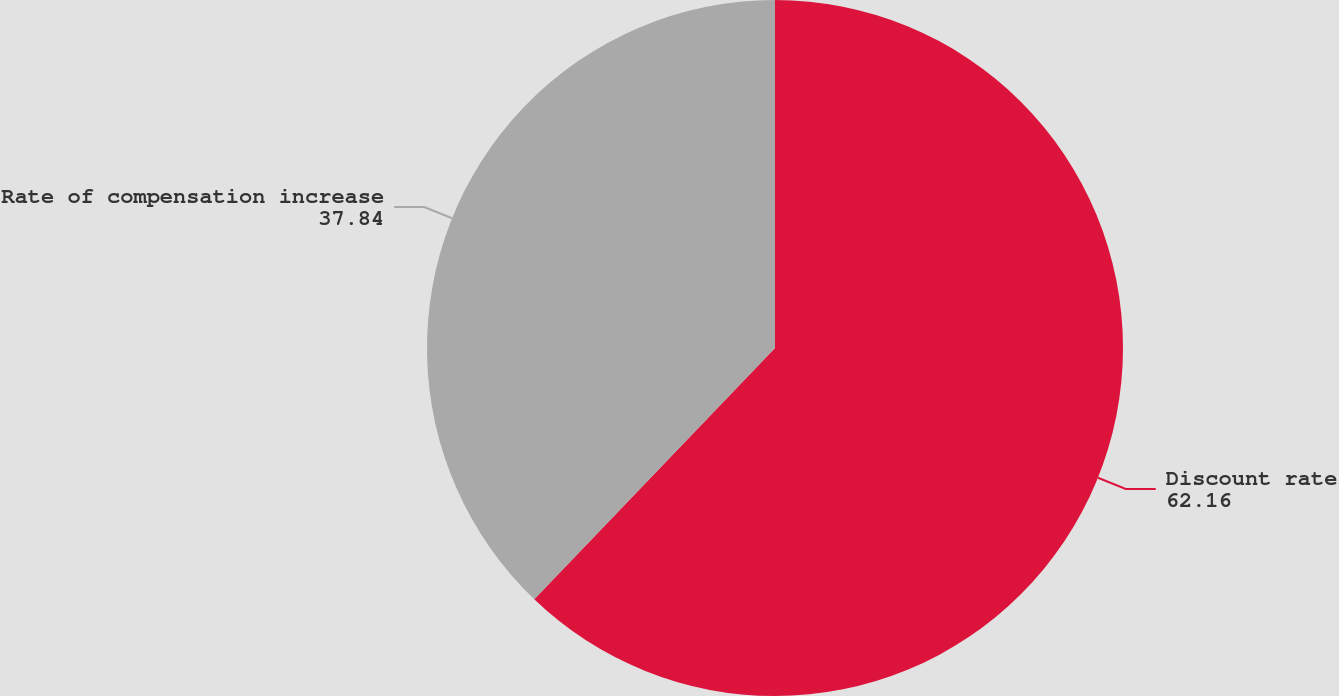Convert chart. <chart><loc_0><loc_0><loc_500><loc_500><pie_chart><fcel>Discount rate<fcel>Rate of compensation increase<nl><fcel>62.16%<fcel>37.84%<nl></chart> 